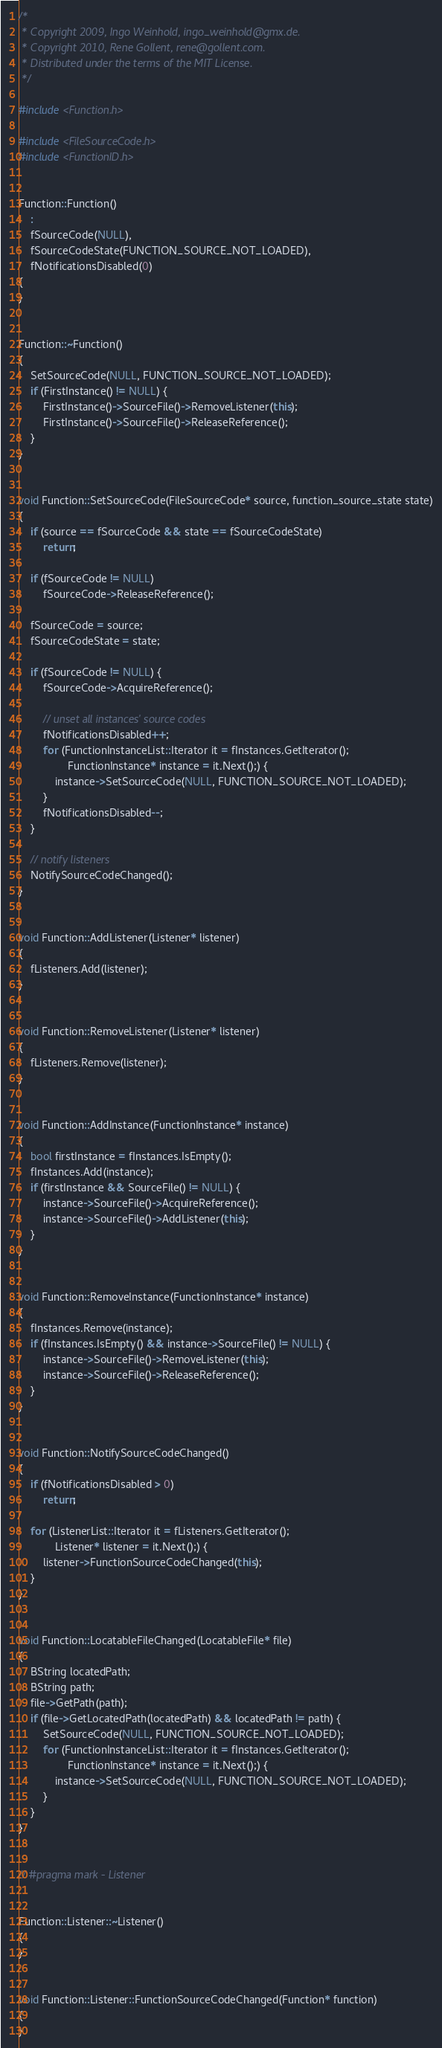<code> <loc_0><loc_0><loc_500><loc_500><_C++_>/*
 * Copyright 2009, Ingo Weinhold, ingo_weinhold@gmx.de.
 * Copyright 2010, Rene Gollent, rene@gollent.com.
 * Distributed under the terms of the MIT License.
 */

#include <Function.h>

#include <FileSourceCode.h>
#include <FunctionID.h>


Function::Function()
	:
	fSourceCode(NULL),
	fSourceCodeState(FUNCTION_SOURCE_NOT_LOADED),
	fNotificationsDisabled(0)
{
}


Function::~Function()
{
	SetSourceCode(NULL, FUNCTION_SOURCE_NOT_LOADED);
	if (FirstInstance() != NULL) {
		FirstInstance()->SourceFile()->RemoveListener(this);
		FirstInstance()->SourceFile()->ReleaseReference();
	}
}


void Function::SetSourceCode(FileSourceCode* source, function_source_state state)
{
	if (source == fSourceCode && state == fSourceCodeState)
		return;

	if (fSourceCode != NULL)
		fSourceCode->ReleaseReference();

	fSourceCode = source;
	fSourceCodeState = state;

	if (fSourceCode != NULL) {
		fSourceCode->AcquireReference();

		// unset all instances' source codes
		fNotificationsDisabled++;
		for (FunctionInstanceList::Iterator it = fInstances.GetIterator();
				FunctionInstance* instance = it.Next();) {
			instance->SetSourceCode(NULL, FUNCTION_SOURCE_NOT_LOADED);
		}
		fNotificationsDisabled--;
	}

	// notify listeners
	NotifySourceCodeChanged();
}


void Function::AddListener(Listener* listener)
{
	fListeners.Add(listener);
}


void Function::RemoveListener(Listener* listener)
{
	fListeners.Remove(listener);
}


void Function::AddInstance(FunctionInstance* instance)
{
	bool firstInstance = fInstances.IsEmpty();
	fInstances.Add(instance);
	if (firstInstance && SourceFile() != NULL) {
		instance->SourceFile()->AcquireReference();
		instance->SourceFile()->AddListener(this);
	}
}


void Function::RemoveInstance(FunctionInstance* instance)
{
	fInstances.Remove(instance);
	if (fInstances.IsEmpty() && instance->SourceFile() != NULL) {
		instance->SourceFile()->RemoveListener(this);
		instance->SourceFile()->ReleaseReference();
	}
}


void Function::NotifySourceCodeChanged()
{
	if (fNotificationsDisabled > 0)
		return;

	for (ListenerList::Iterator it = fListeners.GetIterator();
			Listener* listener = it.Next();) {
		listener->FunctionSourceCodeChanged(this);
	}
}


void Function::LocatableFileChanged(LocatableFile* file)
{
	BString locatedPath;
	BString path;
	file->GetPath(path);
	if (file->GetLocatedPath(locatedPath) && locatedPath != path) {
		SetSourceCode(NULL, FUNCTION_SOURCE_NOT_LOADED);
		for (FunctionInstanceList::Iterator it = fInstances.GetIterator();
				FunctionInstance* instance = it.Next();) {
			instance->SetSourceCode(NULL, FUNCTION_SOURCE_NOT_LOADED);
		}
	}
}


// #pragma mark - Listener


Function::Listener::~Listener()
{
}


void Function::Listener::FunctionSourceCodeChanged(Function* function)
{
}
</code> 